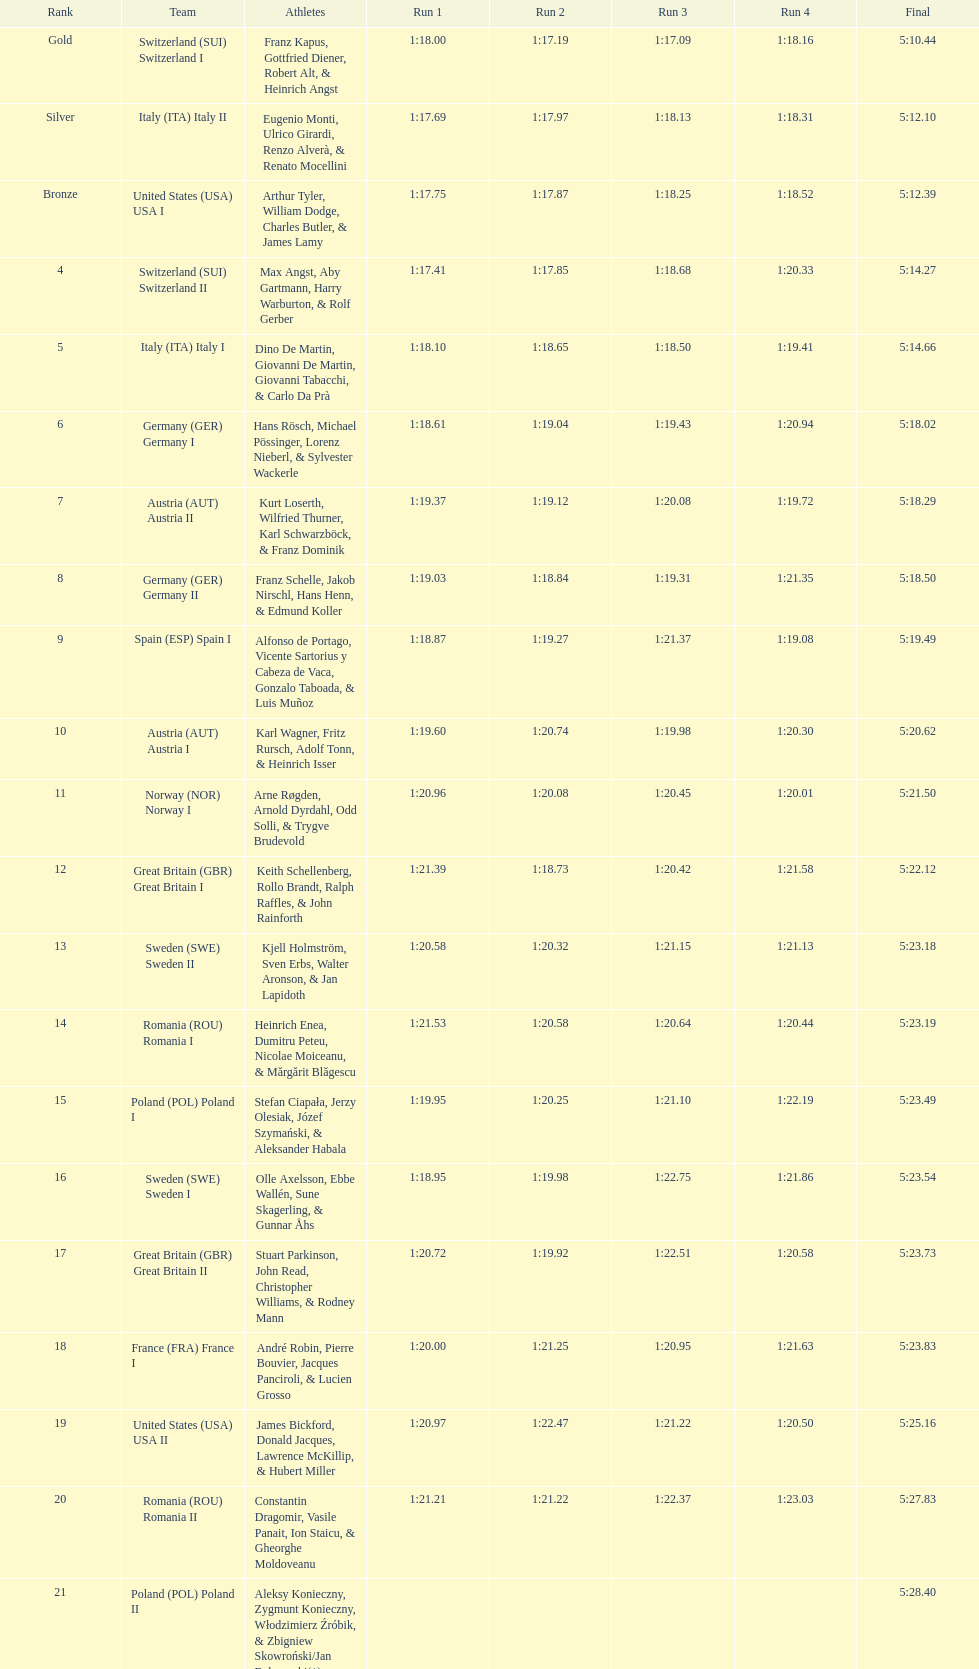What was the number of teams in germany? 2. 